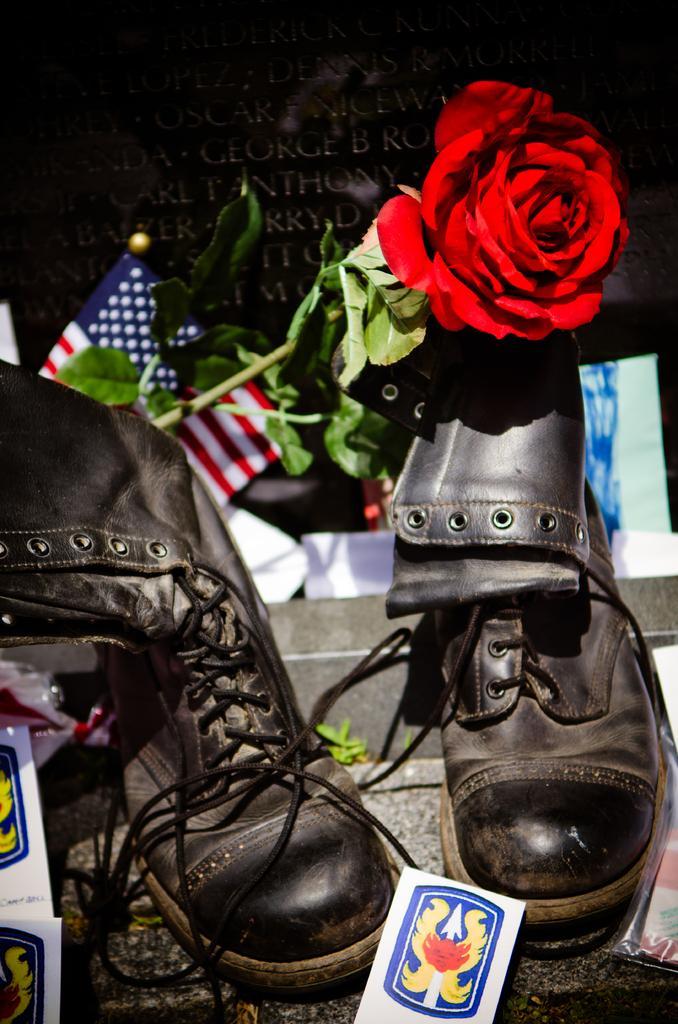Describe this image in one or two sentences. In this image there is a pair of shoes, rose flower with leaves, flat and some other things, in the background there is some text. 